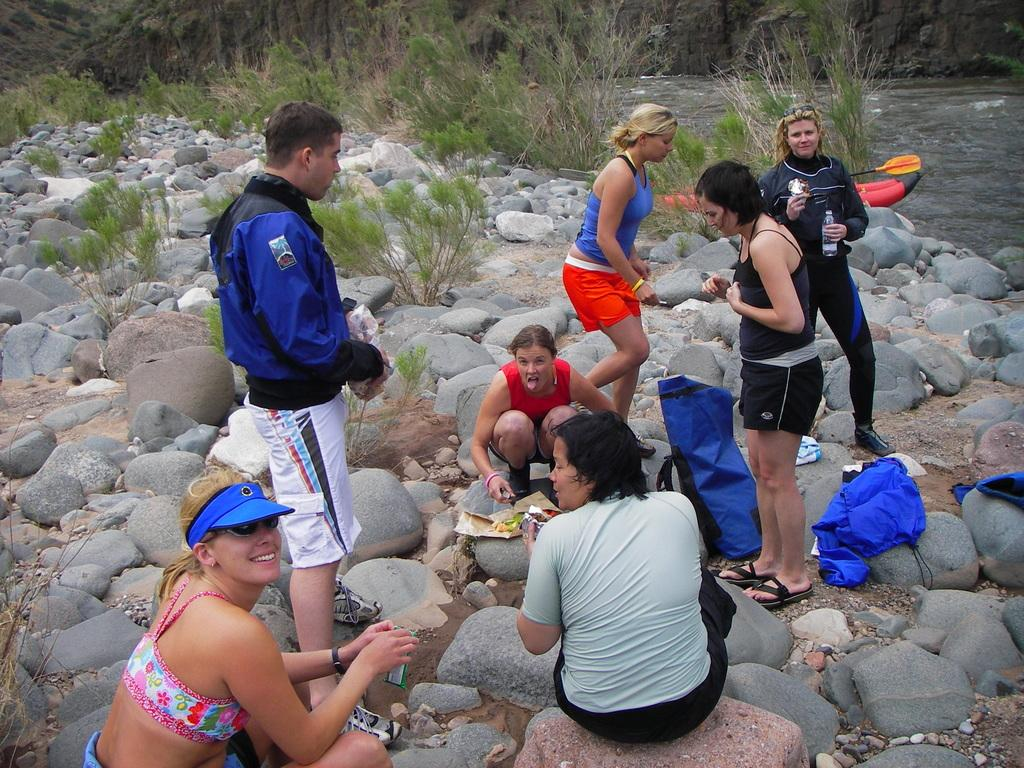What is the main subject of the image? The main subject of the image is people. Where are the people located in the image? The people are on stones in the center of the image. What type of vegetation can be seen in the background of the image? There is grass in the background of the image. What else is visible in the background of the image? There is water visible in the background of the image. What type of comfort can be seen in the image? There is no specific comfort item present in the image; it features people standing on stones with grass and water in the background. 